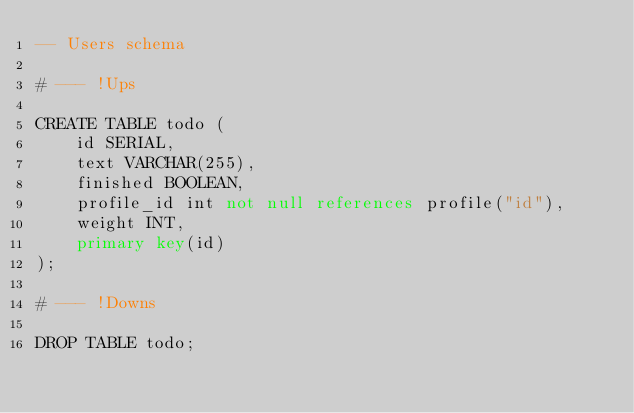<code> <loc_0><loc_0><loc_500><loc_500><_SQL_>-- Users schema

# --- !Ups

CREATE TABLE todo (
    id SERIAL,
    text VARCHAR(255),
    finished BOOLEAN,
    profile_id int not null references profile("id"),
    weight INT,
    primary key(id)
);

# --- !Downs

DROP TABLE todo;</code> 